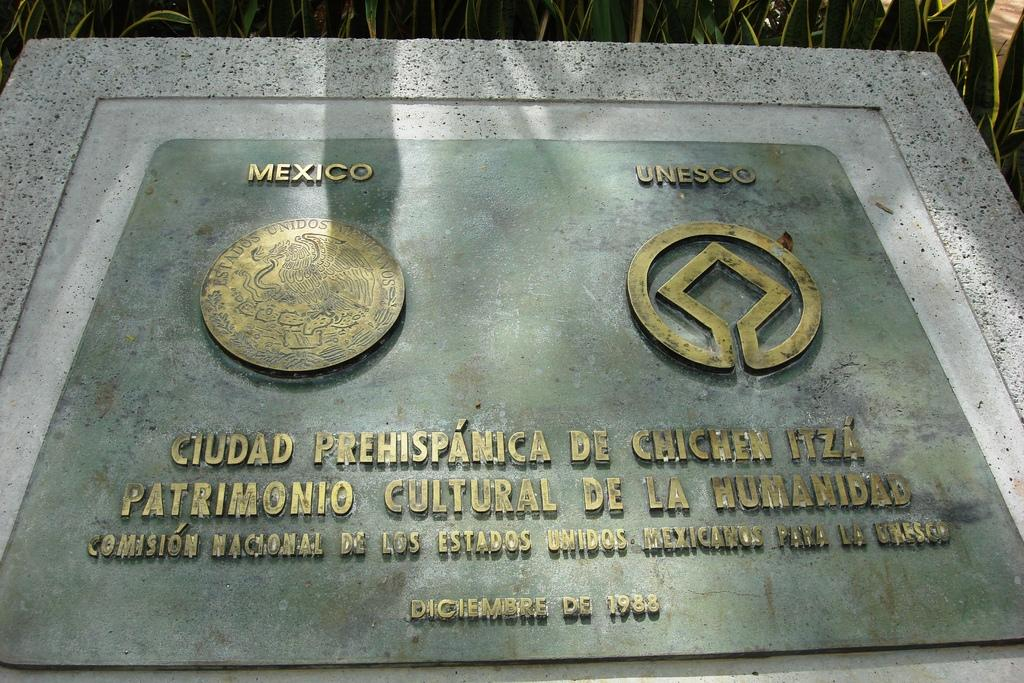Provide a one-sentence caption for the provided image. A plaque featuring logos of Mexico and Unesco. 